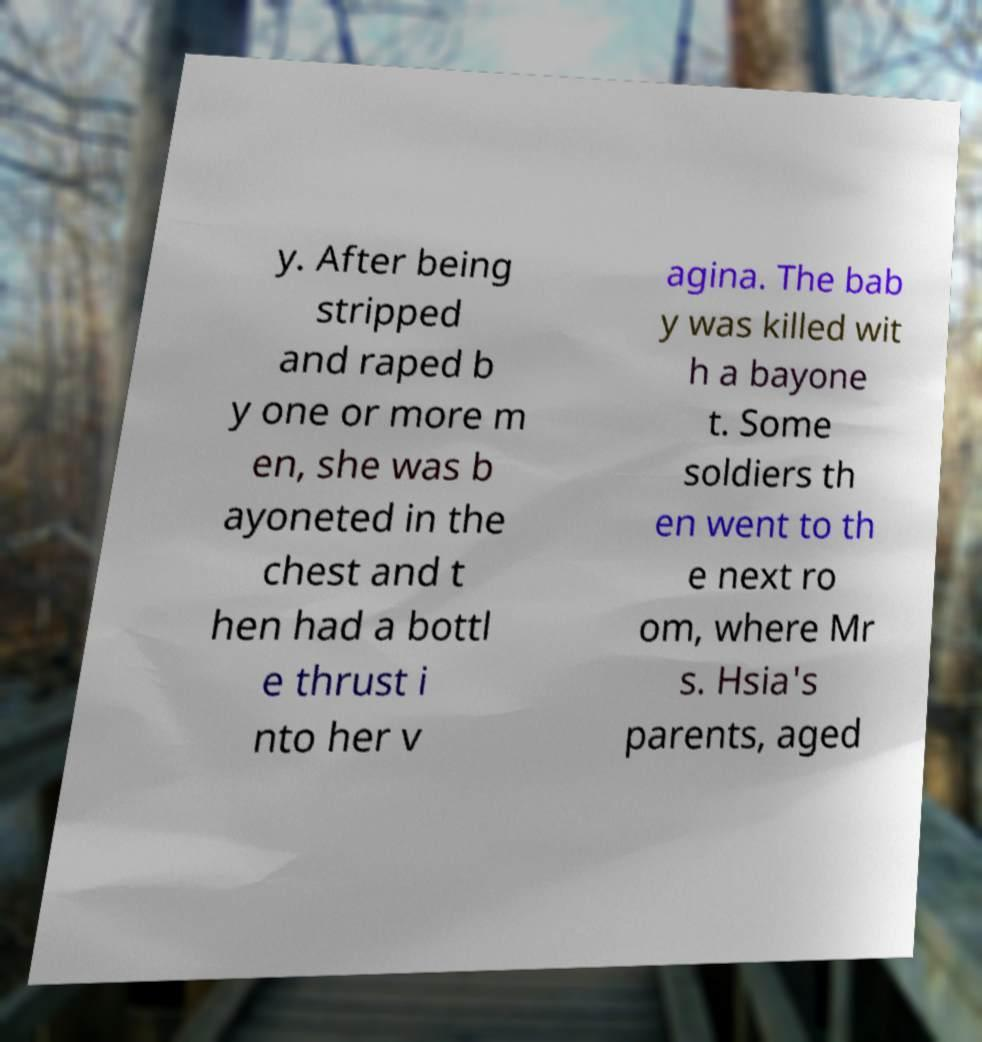Please identify and transcribe the text found in this image. y. After being stripped and raped b y one or more m en, she was b ayoneted in the chest and t hen had a bottl e thrust i nto her v agina. The bab y was killed wit h a bayone t. Some soldiers th en went to th e next ro om, where Mr s. Hsia's parents, aged 